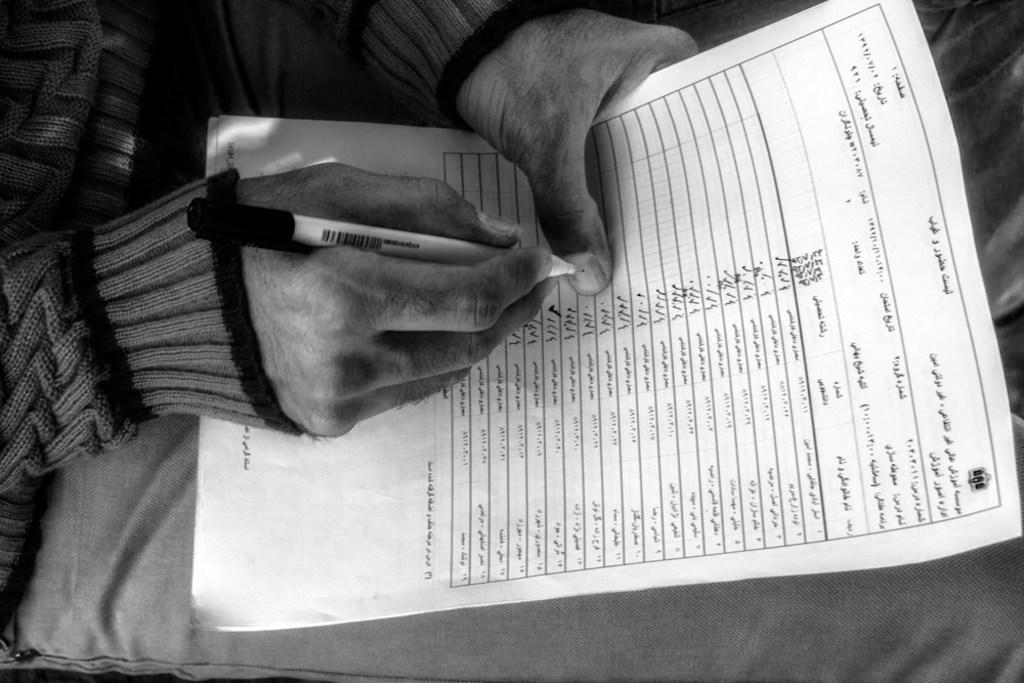What is the main subject of the image? There is a person in the image. What is the person holding in the image? The person is holding a white paper. What is the person doing with the paper? The person is writing on the paper with a pen. Can you tell me how many goldfish are swimming in the image? There are no goldfish present in the image; it features a person holding a white paper and writing on it with a pen. 